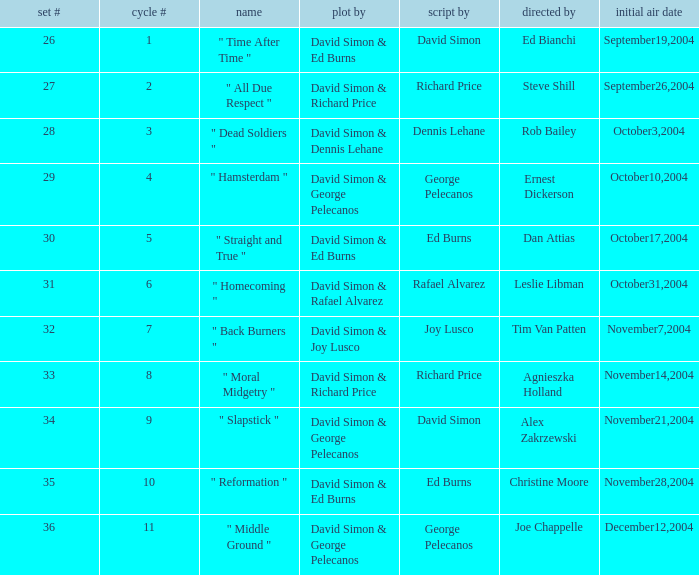Could you parse the entire table? {'header': ['set #', 'cycle #', 'name', 'plot by', 'script by', 'directed by', 'initial air date'], 'rows': [['26', '1', '" Time After Time "', 'David Simon & Ed Burns', 'David Simon', 'Ed Bianchi', 'September19,2004'], ['27', '2', '" All Due Respect "', 'David Simon & Richard Price', 'Richard Price', 'Steve Shill', 'September26,2004'], ['28', '3', '" Dead Soldiers "', 'David Simon & Dennis Lehane', 'Dennis Lehane', 'Rob Bailey', 'October3,2004'], ['29', '4', '" Hamsterdam "', 'David Simon & George Pelecanos', 'George Pelecanos', 'Ernest Dickerson', 'October10,2004'], ['30', '5', '" Straight and True "', 'David Simon & Ed Burns', 'Ed Burns', 'Dan Attias', 'October17,2004'], ['31', '6', '" Homecoming "', 'David Simon & Rafael Alvarez', 'Rafael Alvarez', 'Leslie Libman', 'October31,2004'], ['32', '7', '" Back Burners "', 'David Simon & Joy Lusco', 'Joy Lusco', 'Tim Van Patten', 'November7,2004'], ['33', '8', '" Moral Midgetry "', 'David Simon & Richard Price', 'Richard Price', 'Agnieszka Holland', 'November14,2004'], ['34', '9', '" Slapstick "', 'David Simon & George Pelecanos', 'David Simon', 'Alex Zakrzewski', 'November21,2004'], ['35', '10', '" Reformation "', 'David Simon & Ed Burns', 'Ed Burns', 'Christine Moore', 'November28,2004'], ['36', '11', '" Middle Ground "', 'David Simon & George Pelecanos', 'George Pelecanos', 'Joe Chappelle', 'December12,2004']]} What is the total number of values for "Teleplay by" category for series # 35? 1.0. 